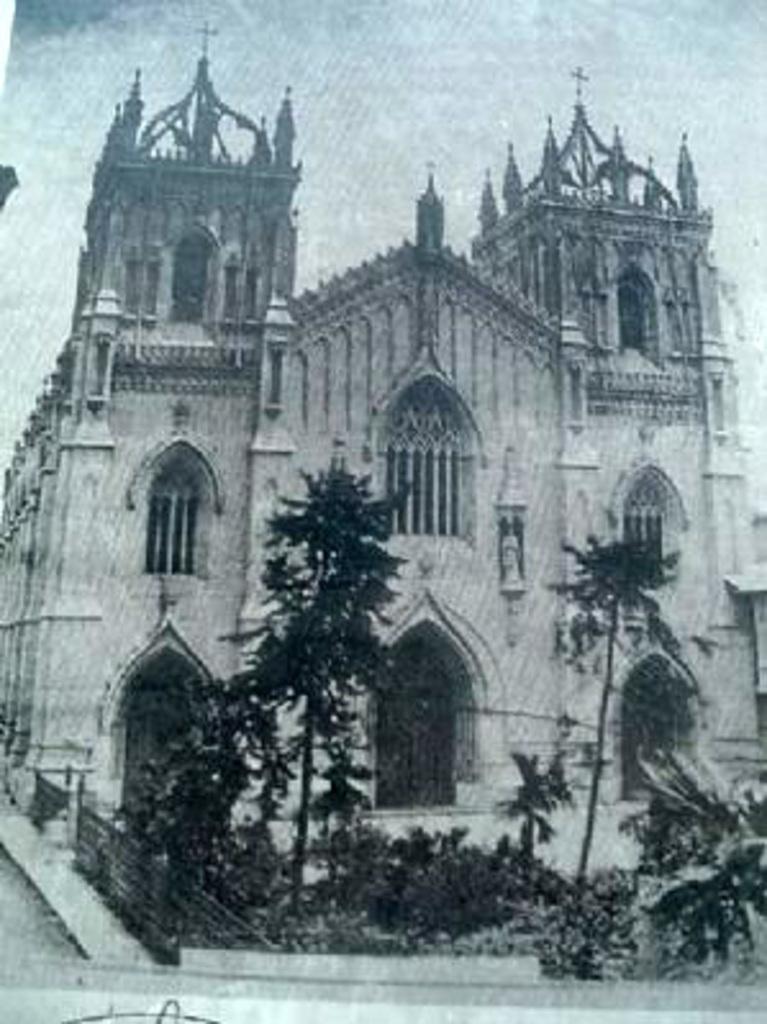In one or two sentences, can you explain what this image depicts? In the center of the image there is a photo of a church and there are trees. 